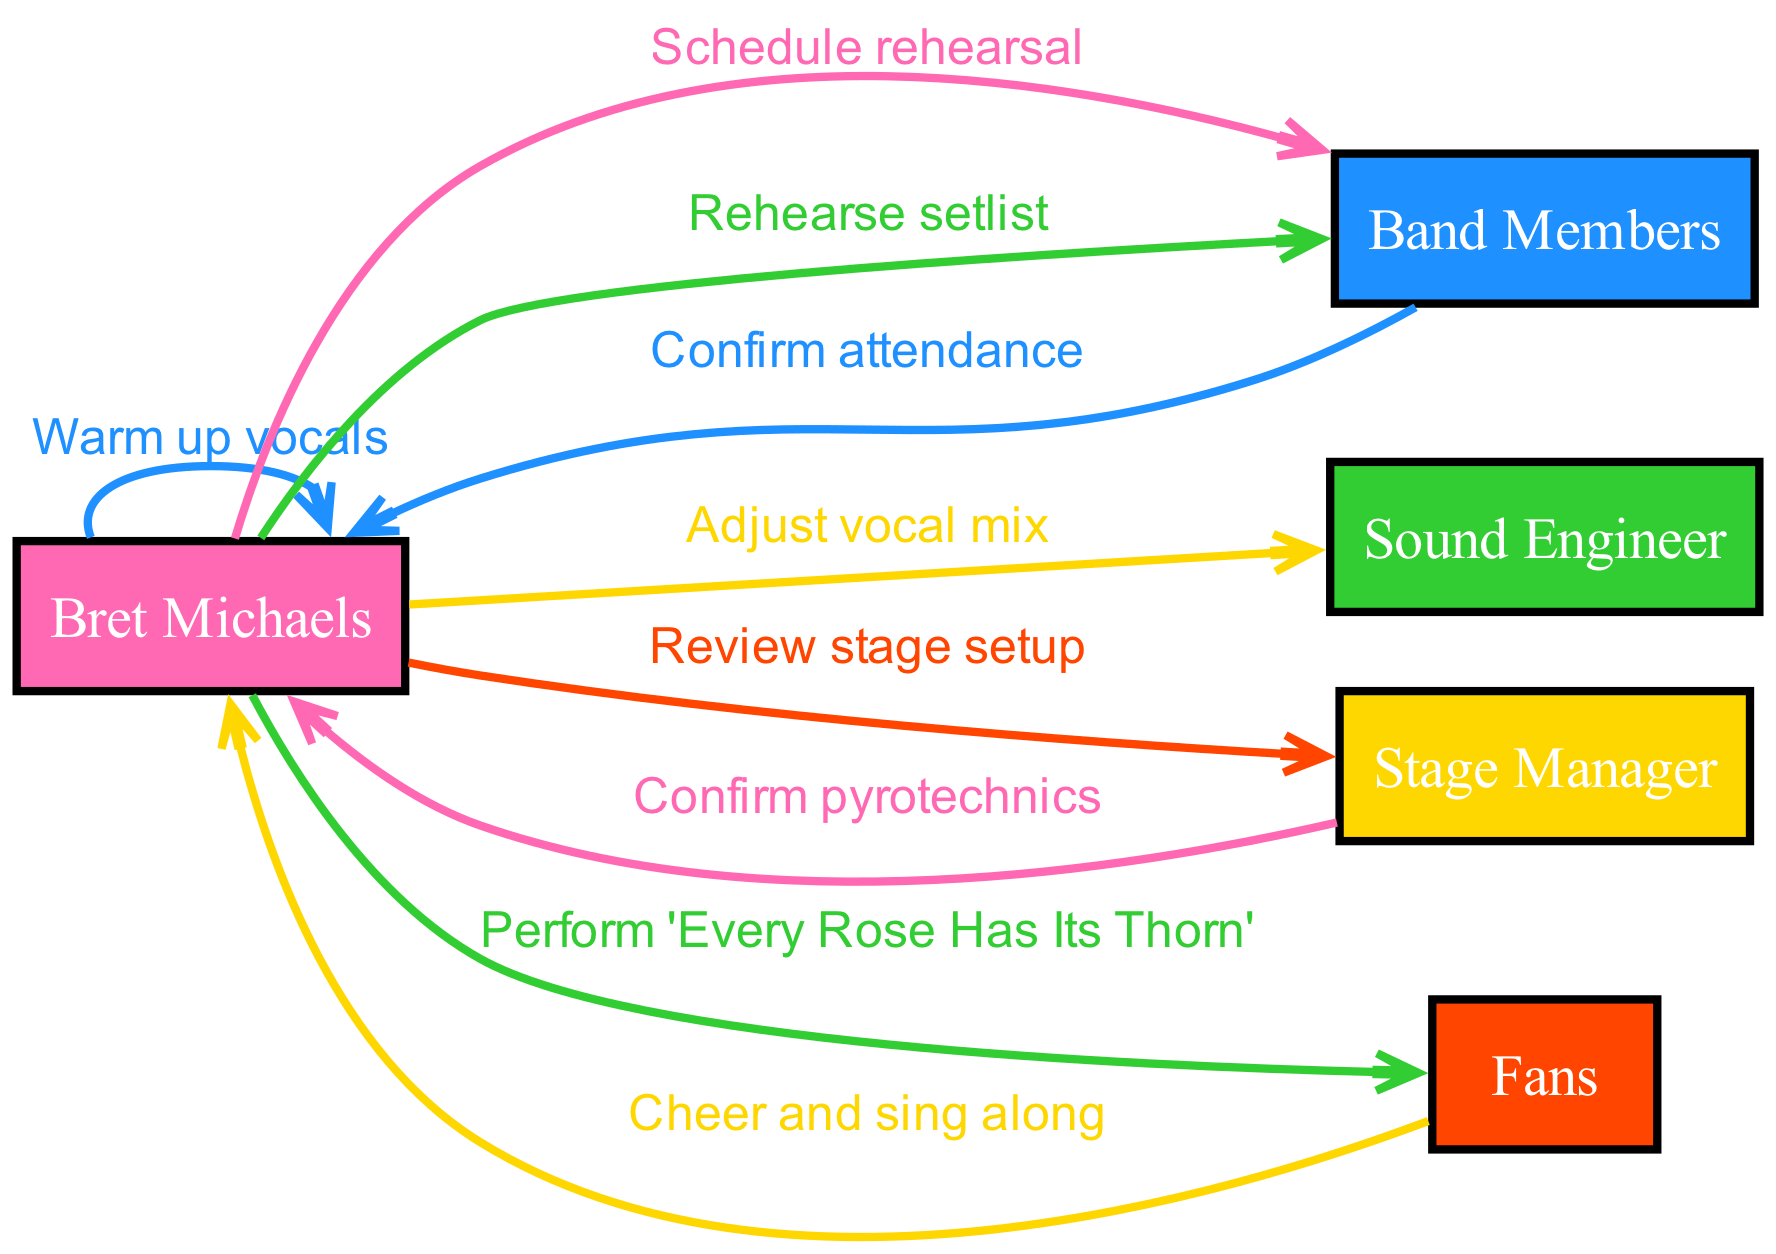What is the first action taken by Bret Michaels? The first action in the sequence is "Schedule rehearsal," which is initiated by Bret Michaels towards the Band Members.
Answer: Schedule rehearsal How many actors are involved in the sequence? There are five actors mentioned in the sequence: Bret Michaels, Band Members, Sound Engineer, Stage Manager, and Fans.
Answer: Five What action follows "Confirm attendance"? The action that directly follows "Confirm attendance" is "Rehearse setlist," which is initiated by Bret Michaels to the Band Members.
Answer: Rehearse setlist Who does Bret Michaels warm up vocals to? Bret Michaels warms up vocals to himself, as that action is directed from Bret Michaels back to Bret Michaels.
Answer: Himself What is the final action in the sequence? The final action in the sequence is "Cheer and sing along," which is performed by the Fans in response to Bret Michaels' performance.
Answer: Cheer and sing along Which actor is responsible for confirming pyrotechnics? The Stage Manager is responsible for confirming pyrotechnics, as indicated by the action directed from the Stage Manager to Bret Michaels.
Answer: Stage Manager How many interactions involve Bret Michaels directly communicating with others? There are four interactions (actions) where Bret Michaels communicates directly with other actors: "Schedule rehearsal," "Rehearse setlist," "Adjust vocal mix," and "Review stage setup."
Answer: Four What action is initiated after the "Review stage setup" action? After the "Review stage setup," the next action initiated by Bret Michaels is "Warm up vocals," which follows in the sequence.
Answer: Warm up vocals Who are the recipients of the performance action? The recipients of the performance action, "Perform 'Every Rose Has Its Thorn,'" are the Fans, as indicated in the sequence.
Answer: Fans 